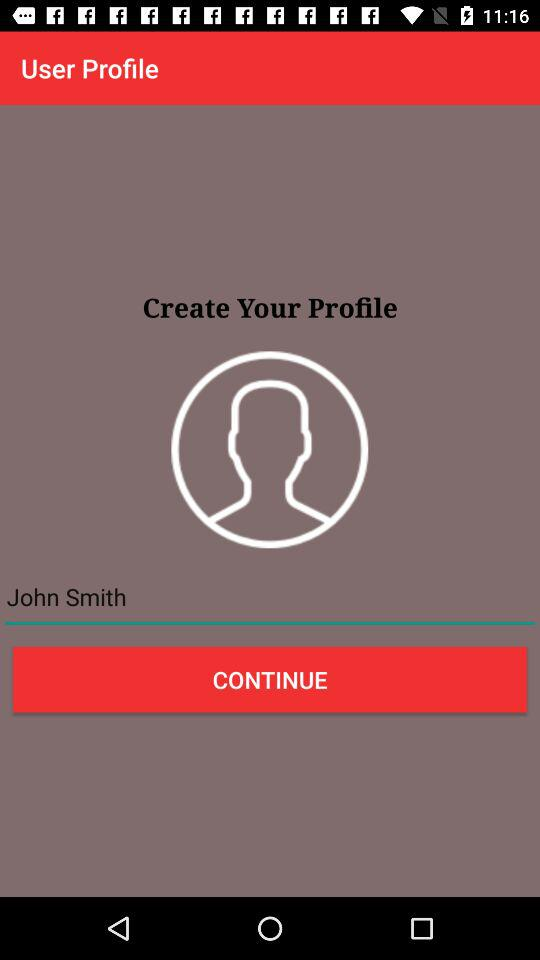What are the names of different security lock types? The names of different security lock types are "Password Lock", "Pattern Lock" and "Pin Lock". 